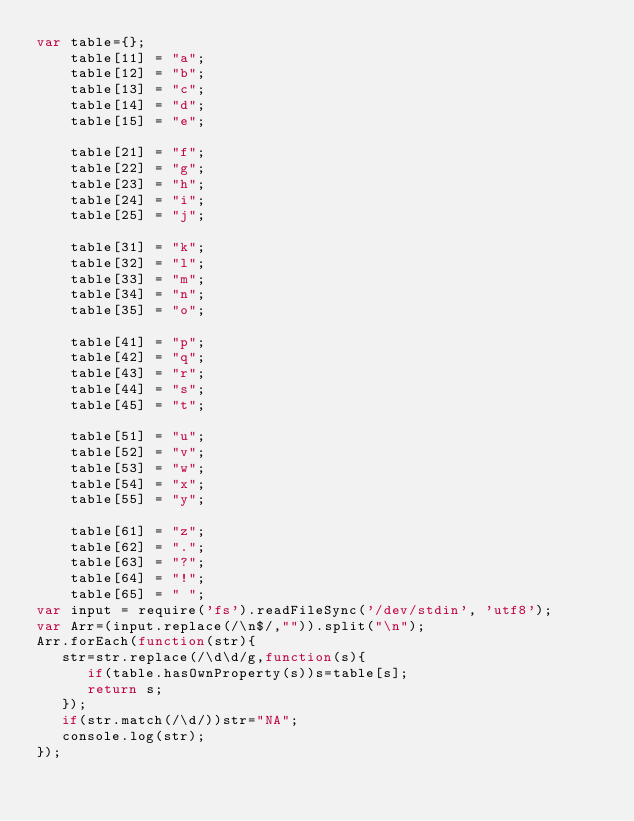Convert code to text. <code><loc_0><loc_0><loc_500><loc_500><_JavaScript_>var table={};
    table[11] = "a";
    table[12] = "b";
    table[13] = "c";
    table[14] = "d";
    table[15] = "e";
 
    table[21] = "f";
    table[22] = "g";
    table[23] = "h";
    table[24] = "i";
    table[25] = "j";
 
    table[31] = "k";
    table[32] = "l";
    table[33] = "m";
    table[34] = "n";
    table[35] = "o";
 
    table[41] = "p";
    table[42] = "q";
    table[43] = "r";
    table[44] = "s";
    table[45] = "t";
 
    table[51] = "u";
    table[52] = "v";
    table[53] = "w";
    table[54] = "x";
    table[55] = "y";
 
    table[61] = "z";
    table[62] = ".";
    table[63] = "?";
    table[64] = "!";
    table[65] = " ";
var input = require('fs').readFileSync('/dev/stdin', 'utf8');
var Arr=(input.replace(/\n$/,"")).split("\n");
Arr.forEach(function(str){
   str=str.replace(/\d\d/g,function(s){
      if(table.hasOwnProperty(s))s=table[s];
      return s;
   });
   if(str.match(/\d/))str="NA";
   console.log(str);
});</code> 